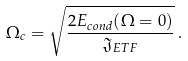Convert formula to latex. <formula><loc_0><loc_0><loc_500><loc_500>\Omega _ { c } = \sqrt { \frac { 2 E _ { c o n d } ( \Omega = 0 ) } { \mathfrak { J } _ { E T F } } } \, .</formula> 